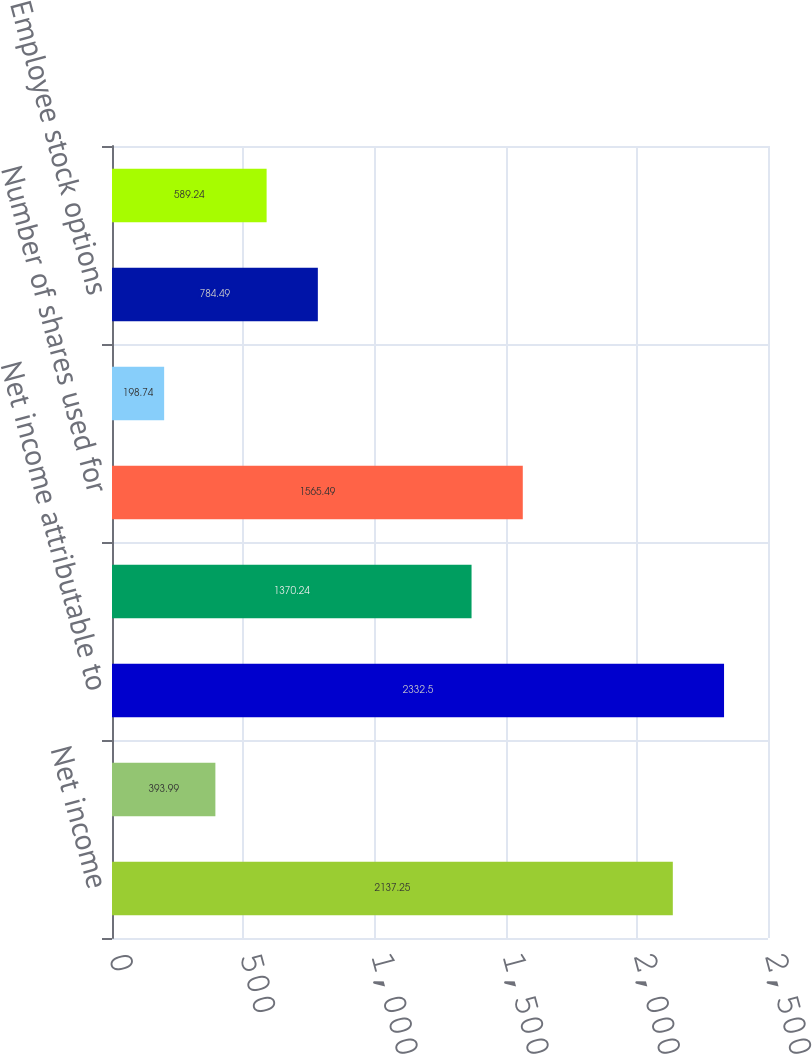Convert chart to OTSL. <chart><loc_0><loc_0><loc_500><loc_500><bar_chart><fcel>Net income<fcel>Less Net income attributable<fcel>Net income attributable to<fcel>Weighted average shares<fcel>Number of shares used for<fcel>Basic EPS<fcel>Employee stock options<fcel>RSUs<nl><fcel>2137.25<fcel>393.99<fcel>2332.5<fcel>1370.24<fcel>1565.49<fcel>198.74<fcel>784.49<fcel>589.24<nl></chart> 